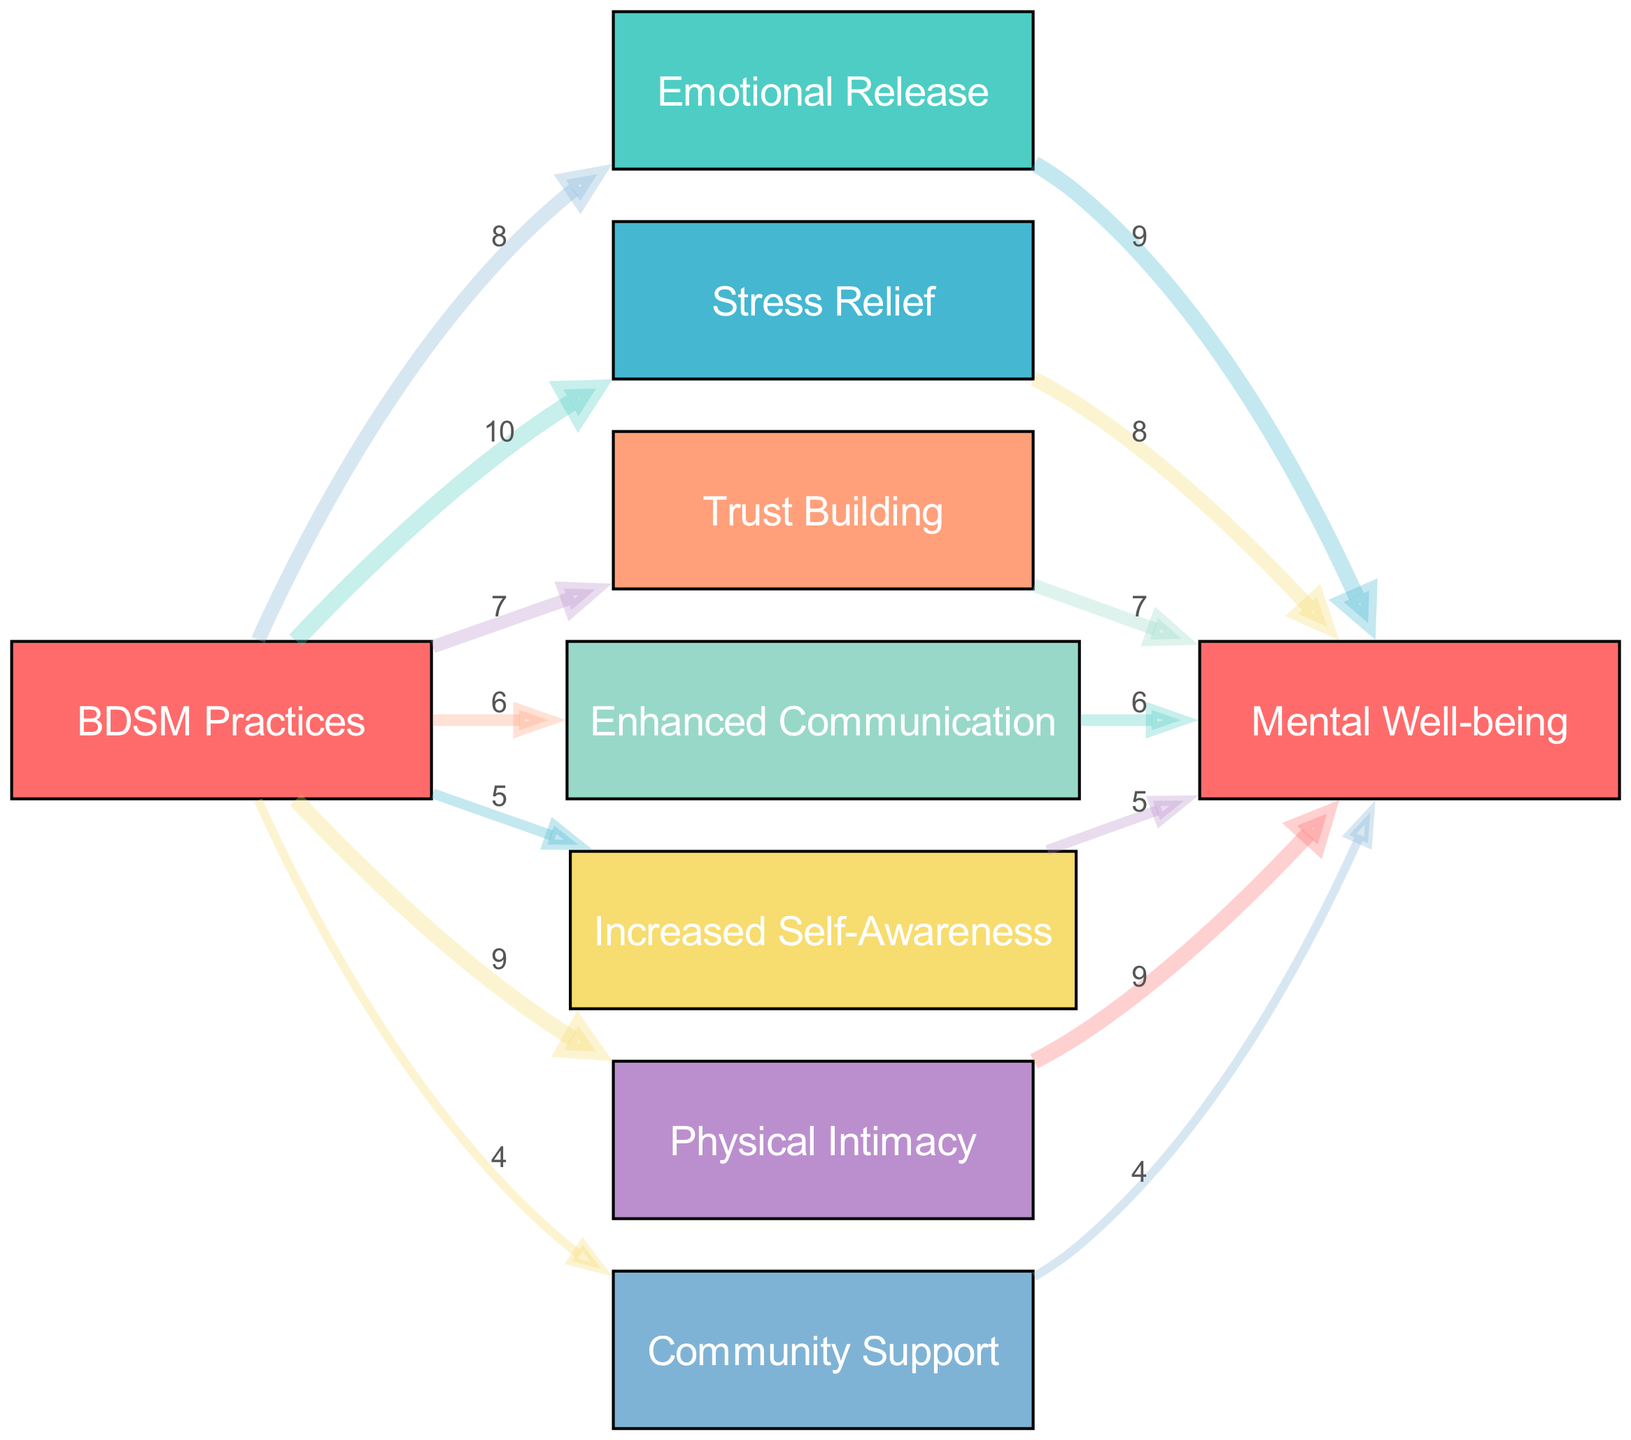What is the total number of nodes in the diagram? The diagram lists a total of 8 unique nodes that represent different aspects associated with BDSM practices and their mental health benefits. By counting each entry under the "nodes" section of the data, we confirm there are 8 nodes.
Answer: 8 Which benefit has the highest value associated with BDSM practices? By examining the links from "BDSM Practices," the benefit with the highest value is "Stress Relief," which has a value of 10. This is the greatest number connecting any benefit to BDSM practices in the diagram.
Answer: Stress Relief What is the value connecting "Physical Intimacy" to "Mental Well-being"? The link from "Physical Intimacy" to "Mental Well-being" indicates a value of 9 in the diagram. This means that the relationship has been quantified as relatively strong, showcasing the link between physical closeness and mental health benefits.
Answer: 9 How many benefits are connected to "BDSM Practices"? The diagram shows that 7 distinct benefits stem from the "BDSM Practices" node. These include Emotional Release, Stress Relief, Trust Building, Enhanced Communication, Increased Self-Awareness, Physical Intimacy, and Community Support. Counting these confirms the number connected to the practices.
Answer: 7 What is the relationship value between "Enhanced Communication" and "Mental Well-being"? The diagram shows a single link from "Enhanced Communication" to "Mental Well-being" with a value of 6. This illustrates the extent to which effective communication can contribute to better mental health outcomes in this context.
Answer: 6 Which benefit related to BDSM practices has the lowest value? Upon reviewing the links from "BDSM Practices," the benefit with the lowest value is "Community Support," which has a value of 4. This indicates that among all benefits linked to BDSM, community support is perceived to be the least beneficial in this analysis.
Answer: Community Support Which two benefits tied to BDSM practices have values greater than 8? From the values associated with BDSM Practices, "Stress Relief" and "Physical Intimacy" both have values greater than 8, specifically 10 and 9, respectively. This indicates that these two benefits are considered more impactful based on the data provided.
Answer: Stress Relief, Physical Intimacy What is the total connection value from "BDSM Practices" to "Mental Well-being"? To find this, we sum the values of all direct links from "BDSM Practices" to those benefits that lead to "Mental Well-being": 9 (Emotional Release) + 8 (Stress Relief) + 7 (Trust Building) + 6 (Enhanced Communication) + 5 (Increased Self-Awareness) + 9 (Physical Intimacy) + 4 (Community Support) = 48 total. Thus, the accumulated influence of these practices on mental well-being is notable and substantial.
Answer: 48 